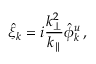<formula> <loc_0><loc_0><loc_500><loc_500>\hat { \xi } _ { k } = i \frac { k _ { \perp } ^ { 2 } } { k _ { \| } } \hat { \phi } _ { k } ^ { u } \, ,</formula> 